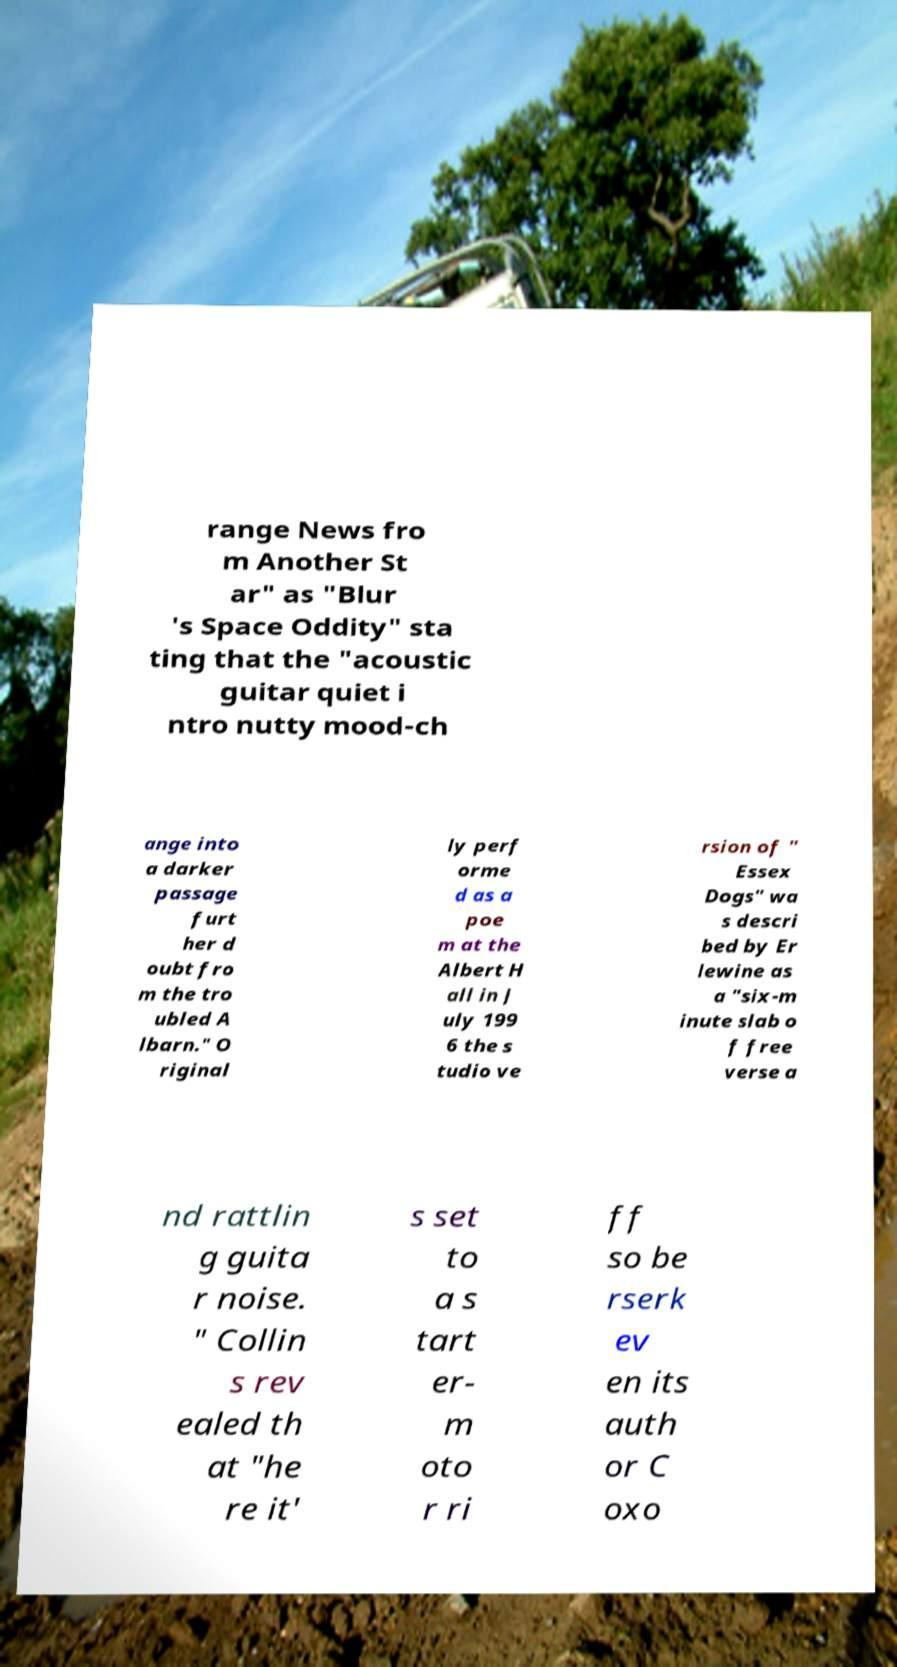Can you read and provide the text displayed in the image?This photo seems to have some interesting text. Can you extract and type it out for me? range News fro m Another St ar" as "Blur 's Space Oddity" sta ting that the "acoustic guitar quiet i ntro nutty mood-ch ange into a darker passage furt her d oubt fro m the tro ubled A lbarn." O riginal ly perf orme d as a poe m at the Albert H all in J uly 199 6 the s tudio ve rsion of " Essex Dogs" wa s descri bed by Er lewine as a "six-m inute slab o f free verse a nd rattlin g guita r noise. " Collin s rev ealed th at "he re it' s set to a s tart er- m oto r ri ff so be rserk ev en its auth or C oxo 